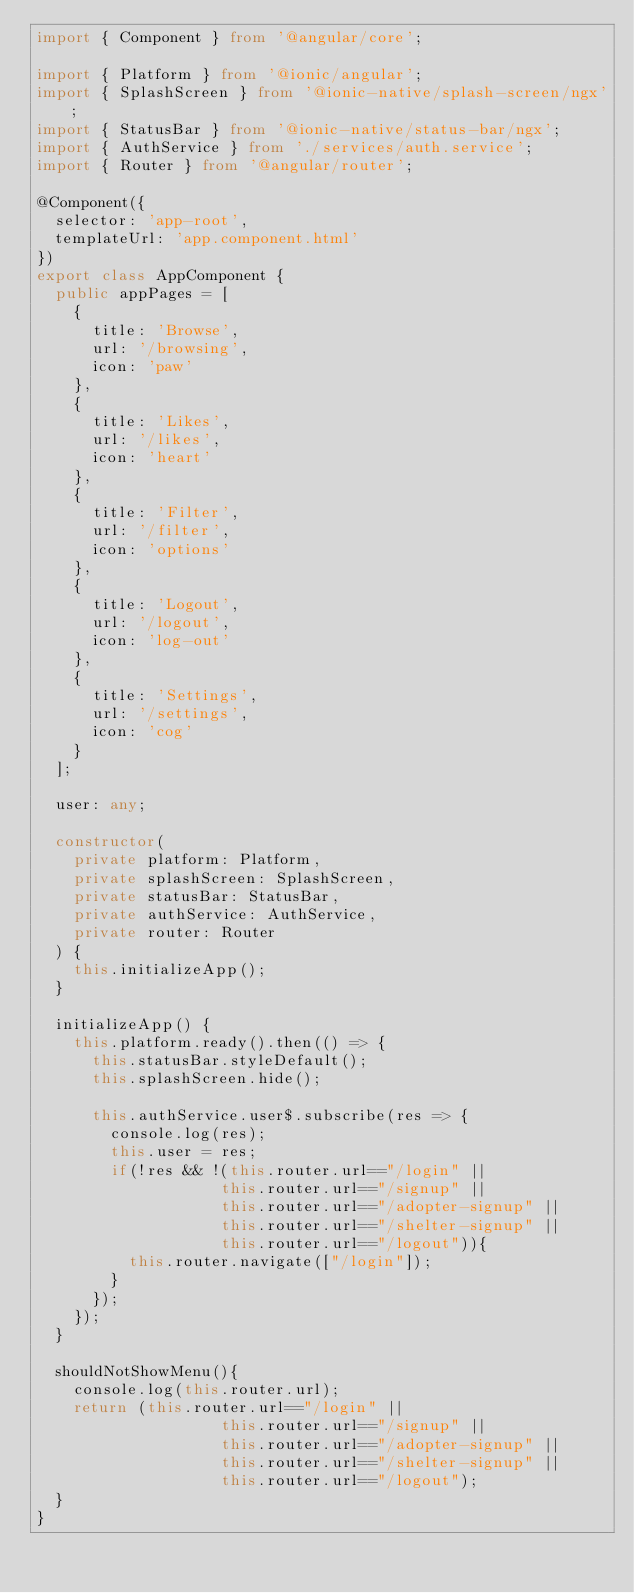Convert code to text. <code><loc_0><loc_0><loc_500><loc_500><_TypeScript_>import { Component } from '@angular/core';

import { Platform } from '@ionic/angular';
import { SplashScreen } from '@ionic-native/splash-screen/ngx';
import { StatusBar } from '@ionic-native/status-bar/ngx';
import { AuthService } from './services/auth.service';
import { Router } from '@angular/router';

@Component({
  selector: 'app-root',
  templateUrl: 'app.component.html'
})
export class AppComponent {
  public appPages = [
    {
      title: 'Browse',
      url: '/browsing',
      icon: 'paw'
    },
    {
      title: 'Likes',
      url: '/likes',
      icon: 'heart'
    },
    {
      title: 'Filter',
      url: '/filter',
      icon: 'options'
    },
    {
      title: 'Logout',
      url: '/logout',
      icon: 'log-out'
    },
    {
      title: 'Settings',
      url: '/settings',
      icon: 'cog'
    }
  ];

  user: any;

  constructor(
    private platform: Platform,
    private splashScreen: SplashScreen,
    private statusBar: StatusBar,
    private authService: AuthService,
    private router: Router
  ) {
    this.initializeApp();
  }

  initializeApp() {
    this.platform.ready().then(() => {
      this.statusBar.styleDefault();
      this.splashScreen.hide();

      this.authService.user$.subscribe(res => {
        console.log(res);
        this.user = res;
        if(!res && !(this.router.url=="/login" || 
                    this.router.url=="/signup" || 
                    this.router.url=="/adopter-signup" || 
                    this.router.url=="/shelter-signup" ||
                    this.router.url=="/logout")){
          this.router.navigate(["/login"]);
        }
      });
    });
  }

  shouldNotShowMenu(){
    console.log(this.router.url);
    return (this.router.url=="/login" || 
                    this.router.url=="/signup" || 
                    this.router.url=="/adopter-signup" || 
                    this.router.url=="/shelter-signup" ||
                    this.router.url=="/logout");
  }
}
</code> 